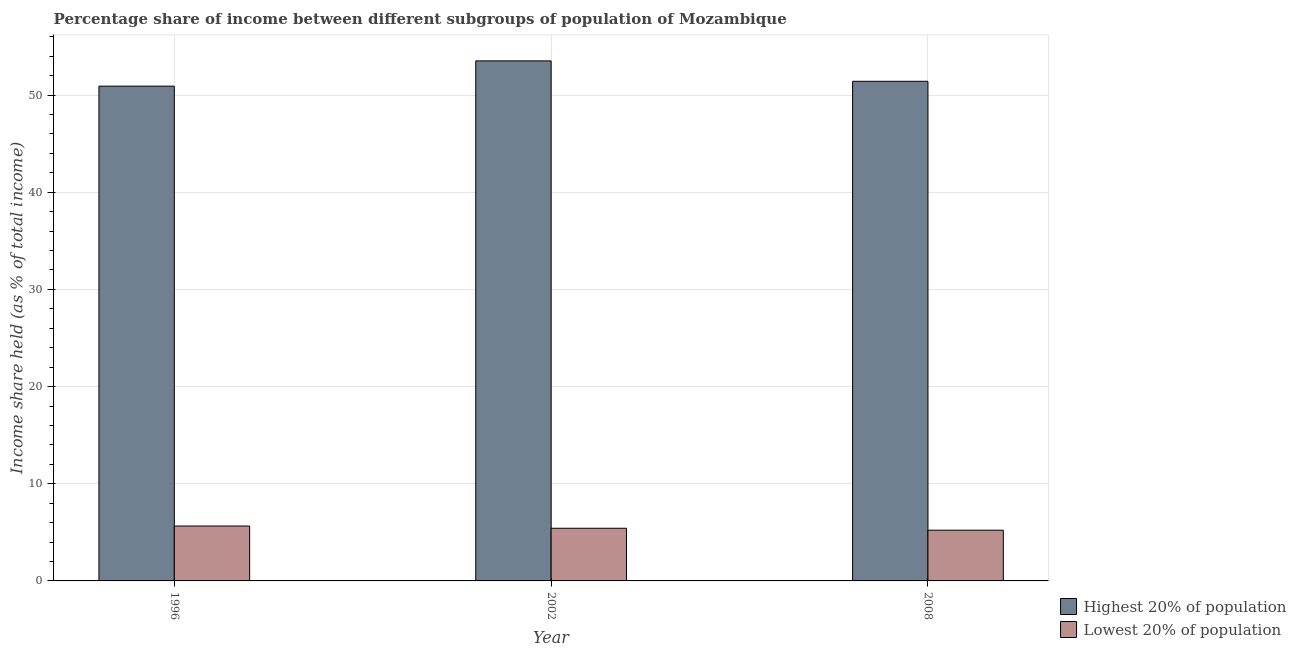How many different coloured bars are there?
Your answer should be compact. 2. How many groups of bars are there?
Give a very brief answer. 3. Are the number of bars per tick equal to the number of legend labels?
Offer a terse response. Yes. How many bars are there on the 2nd tick from the left?
Your answer should be compact. 2. What is the label of the 3rd group of bars from the left?
Keep it short and to the point. 2008. In how many cases, is the number of bars for a given year not equal to the number of legend labels?
Provide a short and direct response. 0. What is the income share held by lowest 20% of the population in 1996?
Provide a short and direct response. 5.65. Across all years, what is the maximum income share held by lowest 20% of the population?
Provide a succinct answer. 5.65. Across all years, what is the minimum income share held by lowest 20% of the population?
Offer a terse response. 5.22. In which year was the income share held by lowest 20% of the population maximum?
Your answer should be very brief. 1996. In which year was the income share held by highest 20% of the population minimum?
Offer a very short reply. 1996. What is the total income share held by highest 20% of the population in the graph?
Provide a short and direct response. 155.86. What is the difference between the income share held by highest 20% of the population in 2008 and the income share held by lowest 20% of the population in 1996?
Provide a succinct answer. 0.5. What is the average income share held by highest 20% of the population per year?
Ensure brevity in your answer.  51.95. In the year 2008, what is the difference between the income share held by lowest 20% of the population and income share held by highest 20% of the population?
Your response must be concise. 0. In how many years, is the income share held by lowest 20% of the population greater than 40 %?
Your response must be concise. 0. What is the ratio of the income share held by lowest 20% of the population in 2002 to that in 2008?
Offer a terse response. 1.04. Is the difference between the income share held by highest 20% of the population in 1996 and 2002 greater than the difference between the income share held by lowest 20% of the population in 1996 and 2002?
Give a very brief answer. No. What is the difference between the highest and the second highest income share held by highest 20% of the population?
Ensure brevity in your answer.  2.1. What is the difference between the highest and the lowest income share held by lowest 20% of the population?
Provide a succinct answer. 0.43. What does the 1st bar from the left in 1996 represents?
Your answer should be very brief. Highest 20% of population. What does the 1st bar from the right in 2008 represents?
Provide a succinct answer. Lowest 20% of population. How many bars are there?
Offer a very short reply. 6. Are all the bars in the graph horizontal?
Keep it short and to the point. No. How many years are there in the graph?
Make the answer very short. 3. Are the values on the major ticks of Y-axis written in scientific E-notation?
Make the answer very short. No. Does the graph contain any zero values?
Your answer should be very brief. No. Does the graph contain grids?
Your response must be concise. Yes. Where does the legend appear in the graph?
Your answer should be compact. Bottom right. How many legend labels are there?
Your answer should be compact. 2. How are the legend labels stacked?
Make the answer very short. Vertical. What is the title of the graph?
Offer a terse response. Percentage share of income between different subgroups of population of Mozambique. What is the label or title of the Y-axis?
Offer a very short reply. Income share held (as % of total income). What is the Income share held (as % of total income) in Highest 20% of population in 1996?
Provide a short and direct response. 50.92. What is the Income share held (as % of total income) in Lowest 20% of population in 1996?
Give a very brief answer. 5.65. What is the Income share held (as % of total income) in Highest 20% of population in 2002?
Your answer should be very brief. 53.52. What is the Income share held (as % of total income) in Lowest 20% of population in 2002?
Offer a terse response. 5.42. What is the Income share held (as % of total income) in Highest 20% of population in 2008?
Keep it short and to the point. 51.42. What is the Income share held (as % of total income) in Lowest 20% of population in 2008?
Keep it short and to the point. 5.22. Across all years, what is the maximum Income share held (as % of total income) in Highest 20% of population?
Offer a very short reply. 53.52. Across all years, what is the maximum Income share held (as % of total income) of Lowest 20% of population?
Your answer should be compact. 5.65. Across all years, what is the minimum Income share held (as % of total income) of Highest 20% of population?
Make the answer very short. 50.92. Across all years, what is the minimum Income share held (as % of total income) in Lowest 20% of population?
Your answer should be compact. 5.22. What is the total Income share held (as % of total income) of Highest 20% of population in the graph?
Give a very brief answer. 155.86. What is the total Income share held (as % of total income) in Lowest 20% of population in the graph?
Offer a very short reply. 16.29. What is the difference between the Income share held (as % of total income) in Lowest 20% of population in 1996 and that in 2002?
Make the answer very short. 0.23. What is the difference between the Income share held (as % of total income) of Highest 20% of population in 1996 and that in 2008?
Make the answer very short. -0.5. What is the difference between the Income share held (as % of total income) of Lowest 20% of population in 1996 and that in 2008?
Provide a succinct answer. 0.43. What is the difference between the Income share held (as % of total income) in Lowest 20% of population in 2002 and that in 2008?
Ensure brevity in your answer.  0.2. What is the difference between the Income share held (as % of total income) in Highest 20% of population in 1996 and the Income share held (as % of total income) in Lowest 20% of population in 2002?
Make the answer very short. 45.5. What is the difference between the Income share held (as % of total income) in Highest 20% of population in 1996 and the Income share held (as % of total income) in Lowest 20% of population in 2008?
Your answer should be compact. 45.7. What is the difference between the Income share held (as % of total income) of Highest 20% of population in 2002 and the Income share held (as % of total income) of Lowest 20% of population in 2008?
Your answer should be compact. 48.3. What is the average Income share held (as % of total income) in Highest 20% of population per year?
Keep it short and to the point. 51.95. What is the average Income share held (as % of total income) in Lowest 20% of population per year?
Offer a very short reply. 5.43. In the year 1996, what is the difference between the Income share held (as % of total income) in Highest 20% of population and Income share held (as % of total income) in Lowest 20% of population?
Your answer should be very brief. 45.27. In the year 2002, what is the difference between the Income share held (as % of total income) of Highest 20% of population and Income share held (as % of total income) of Lowest 20% of population?
Your answer should be compact. 48.1. In the year 2008, what is the difference between the Income share held (as % of total income) of Highest 20% of population and Income share held (as % of total income) of Lowest 20% of population?
Make the answer very short. 46.2. What is the ratio of the Income share held (as % of total income) in Highest 20% of population in 1996 to that in 2002?
Provide a short and direct response. 0.95. What is the ratio of the Income share held (as % of total income) of Lowest 20% of population in 1996 to that in 2002?
Keep it short and to the point. 1.04. What is the ratio of the Income share held (as % of total income) in Highest 20% of population in 1996 to that in 2008?
Offer a very short reply. 0.99. What is the ratio of the Income share held (as % of total income) in Lowest 20% of population in 1996 to that in 2008?
Offer a very short reply. 1.08. What is the ratio of the Income share held (as % of total income) in Highest 20% of population in 2002 to that in 2008?
Keep it short and to the point. 1.04. What is the ratio of the Income share held (as % of total income) of Lowest 20% of population in 2002 to that in 2008?
Ensure brevity in your answer.  1.04. What is the difference between the highest and the second highest Income share held (as % of total income) in Lowest 20% of population?
Offer a terse response. 0.23. What is the difference between the highest and the lowest Income share held (as % of total income) in Lowest 20% of population?
Ensure brevity in your answer.  0.43. 